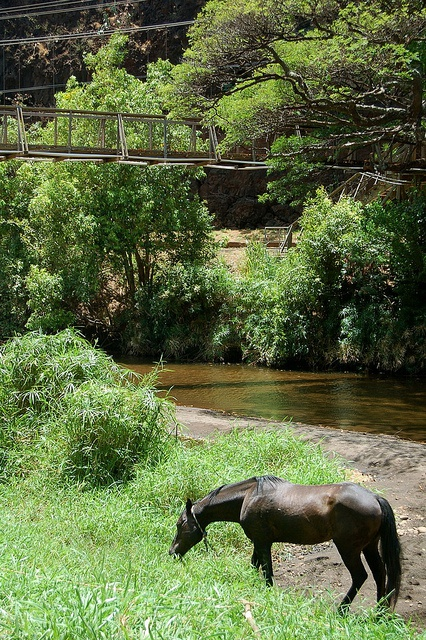Describe the objects in this image and their specific colors. I can see a horse in black, darkgray, gray, and olive tones in this image. 